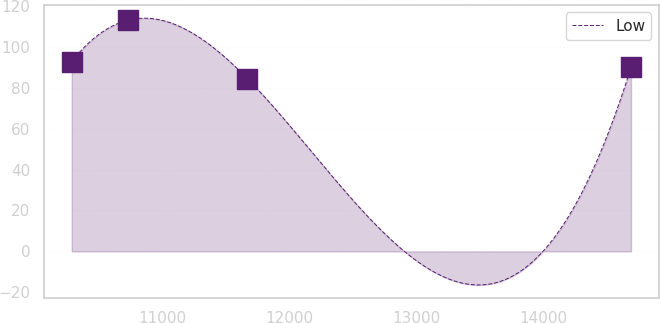Convert chart to OTSL. <chart><loc_0><loc_0><loc_500><loc_500><line_chart><ecel><fcel>Low<nl><fcel>10290.2<fcel>92.76<nl><fcel>10729.7<fcel>112.93<nl><fcel>11671.4<fcel>84.38<nl><fcel>14685.8<fcel>89.9<nl></chart> 